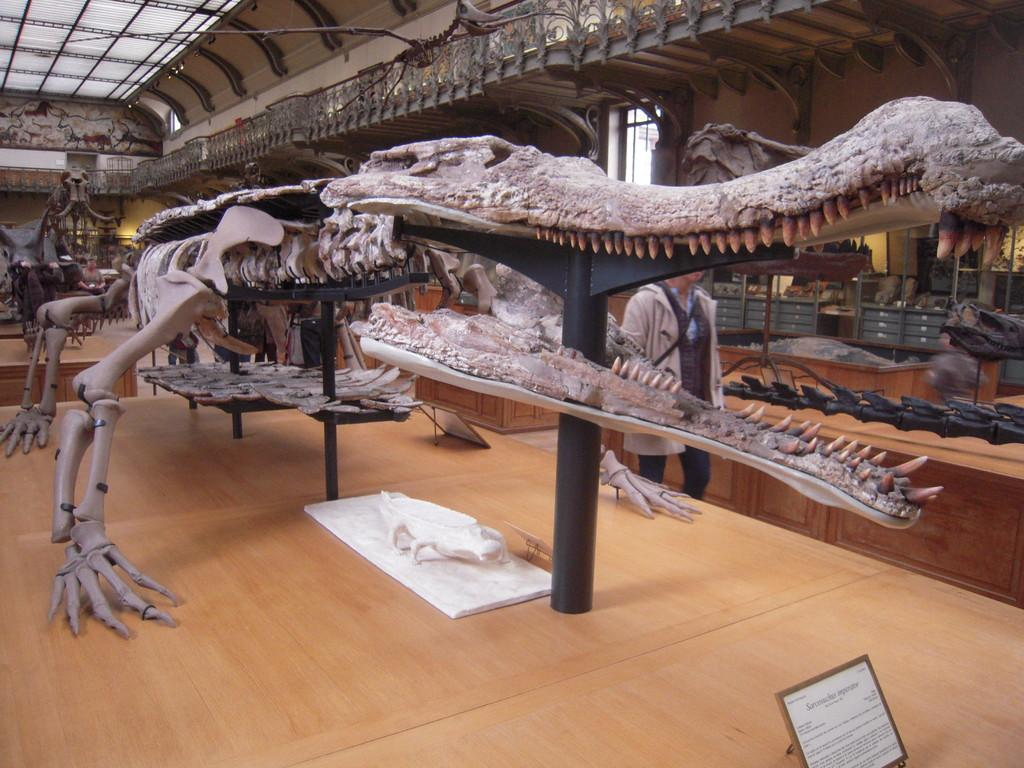What type of place is depicted in the image? The image is of a museum. What can be seen on display in the museum? There are skeletons of an animal on a wooden surface. Is there any additional information provided in the image? Yes, there is a board with text in the image. Are there any people present in the image? Yes, there is a person in the image. What type of home does the person in the image live in? The image does not show the person's home, so it cannot be determined from the image. What topic is being discussed by the person in the image? There is no indication of a discussion taking place in the image. 